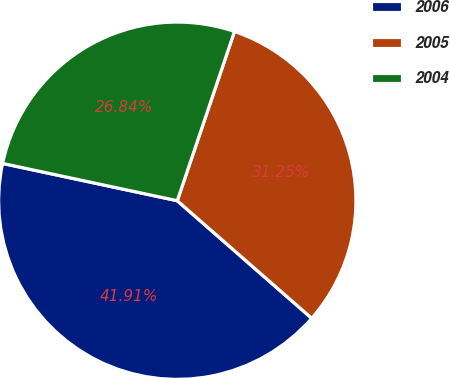Convert chart. <chart><loc_0><loc_0><loc_500><loc_500><pie_chart><fcel>2006<fcel>2005<fcel>2004<nl><fcel>41.91%<fcel>31.25%<fcel>26.84%<nl></chart> 